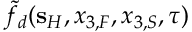<formula> <loc_0><loc_0><loc_500><loc_500>\tilde { f } _ { d } ( { s } _ { H } , x _ { 3 , F } , x _ { 3 , S } , \tau )</formula> 